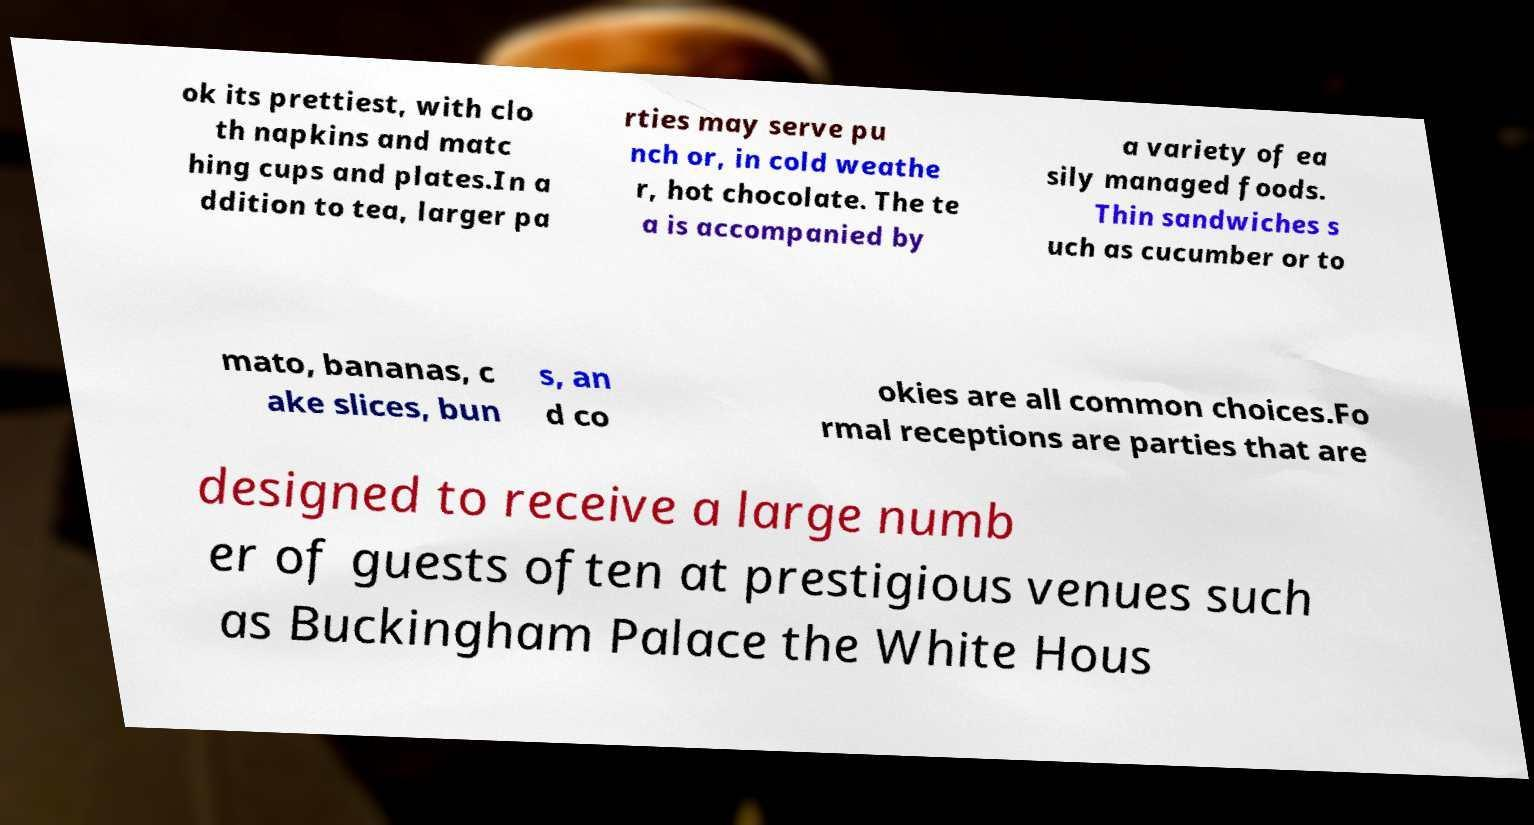Can you read and provide the text displayed in the image?This photo seems to have some interesting text. Can you extract and type it out for me? ok its prettiest, with clo th napkins and matc hing cups and plates.In a ddition to tea, larger pa rties may serve pu nch or, in cold weathe r, hot chocolate. The te a is accompanied by a variety of ea sily managed foods. Thin sandwiches s uch as cucumber or to mato, bananas, c ake slices, bun s, an d co okies are all common choices.Fo rmal receptions are parties that are designed to receive a large numb er of guests often at prestigious venues such as Buckingham Palace the White Hous 